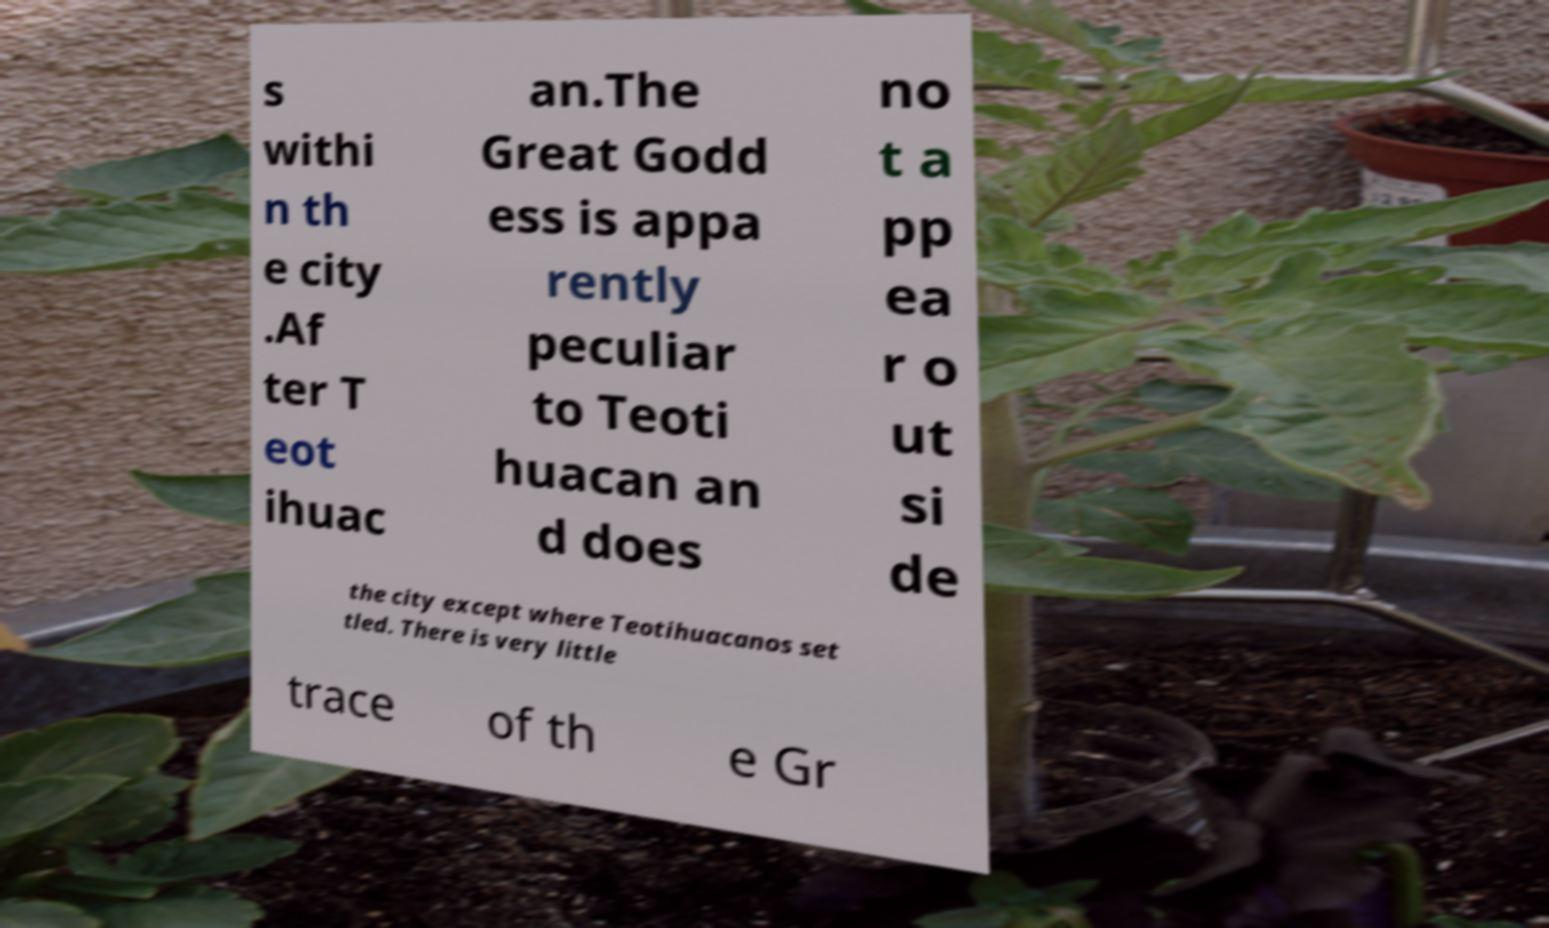I need the written content from this picture converted into text. Can you do that? s withi n th e city .Af ter T eot ihuac an.The Great Godd ess is appa rently peculiar to Teoti huacan an d does no t a pp ea r o ut si de the city except where Teotihuacanos set tled. There is very little trace of th e Gr 